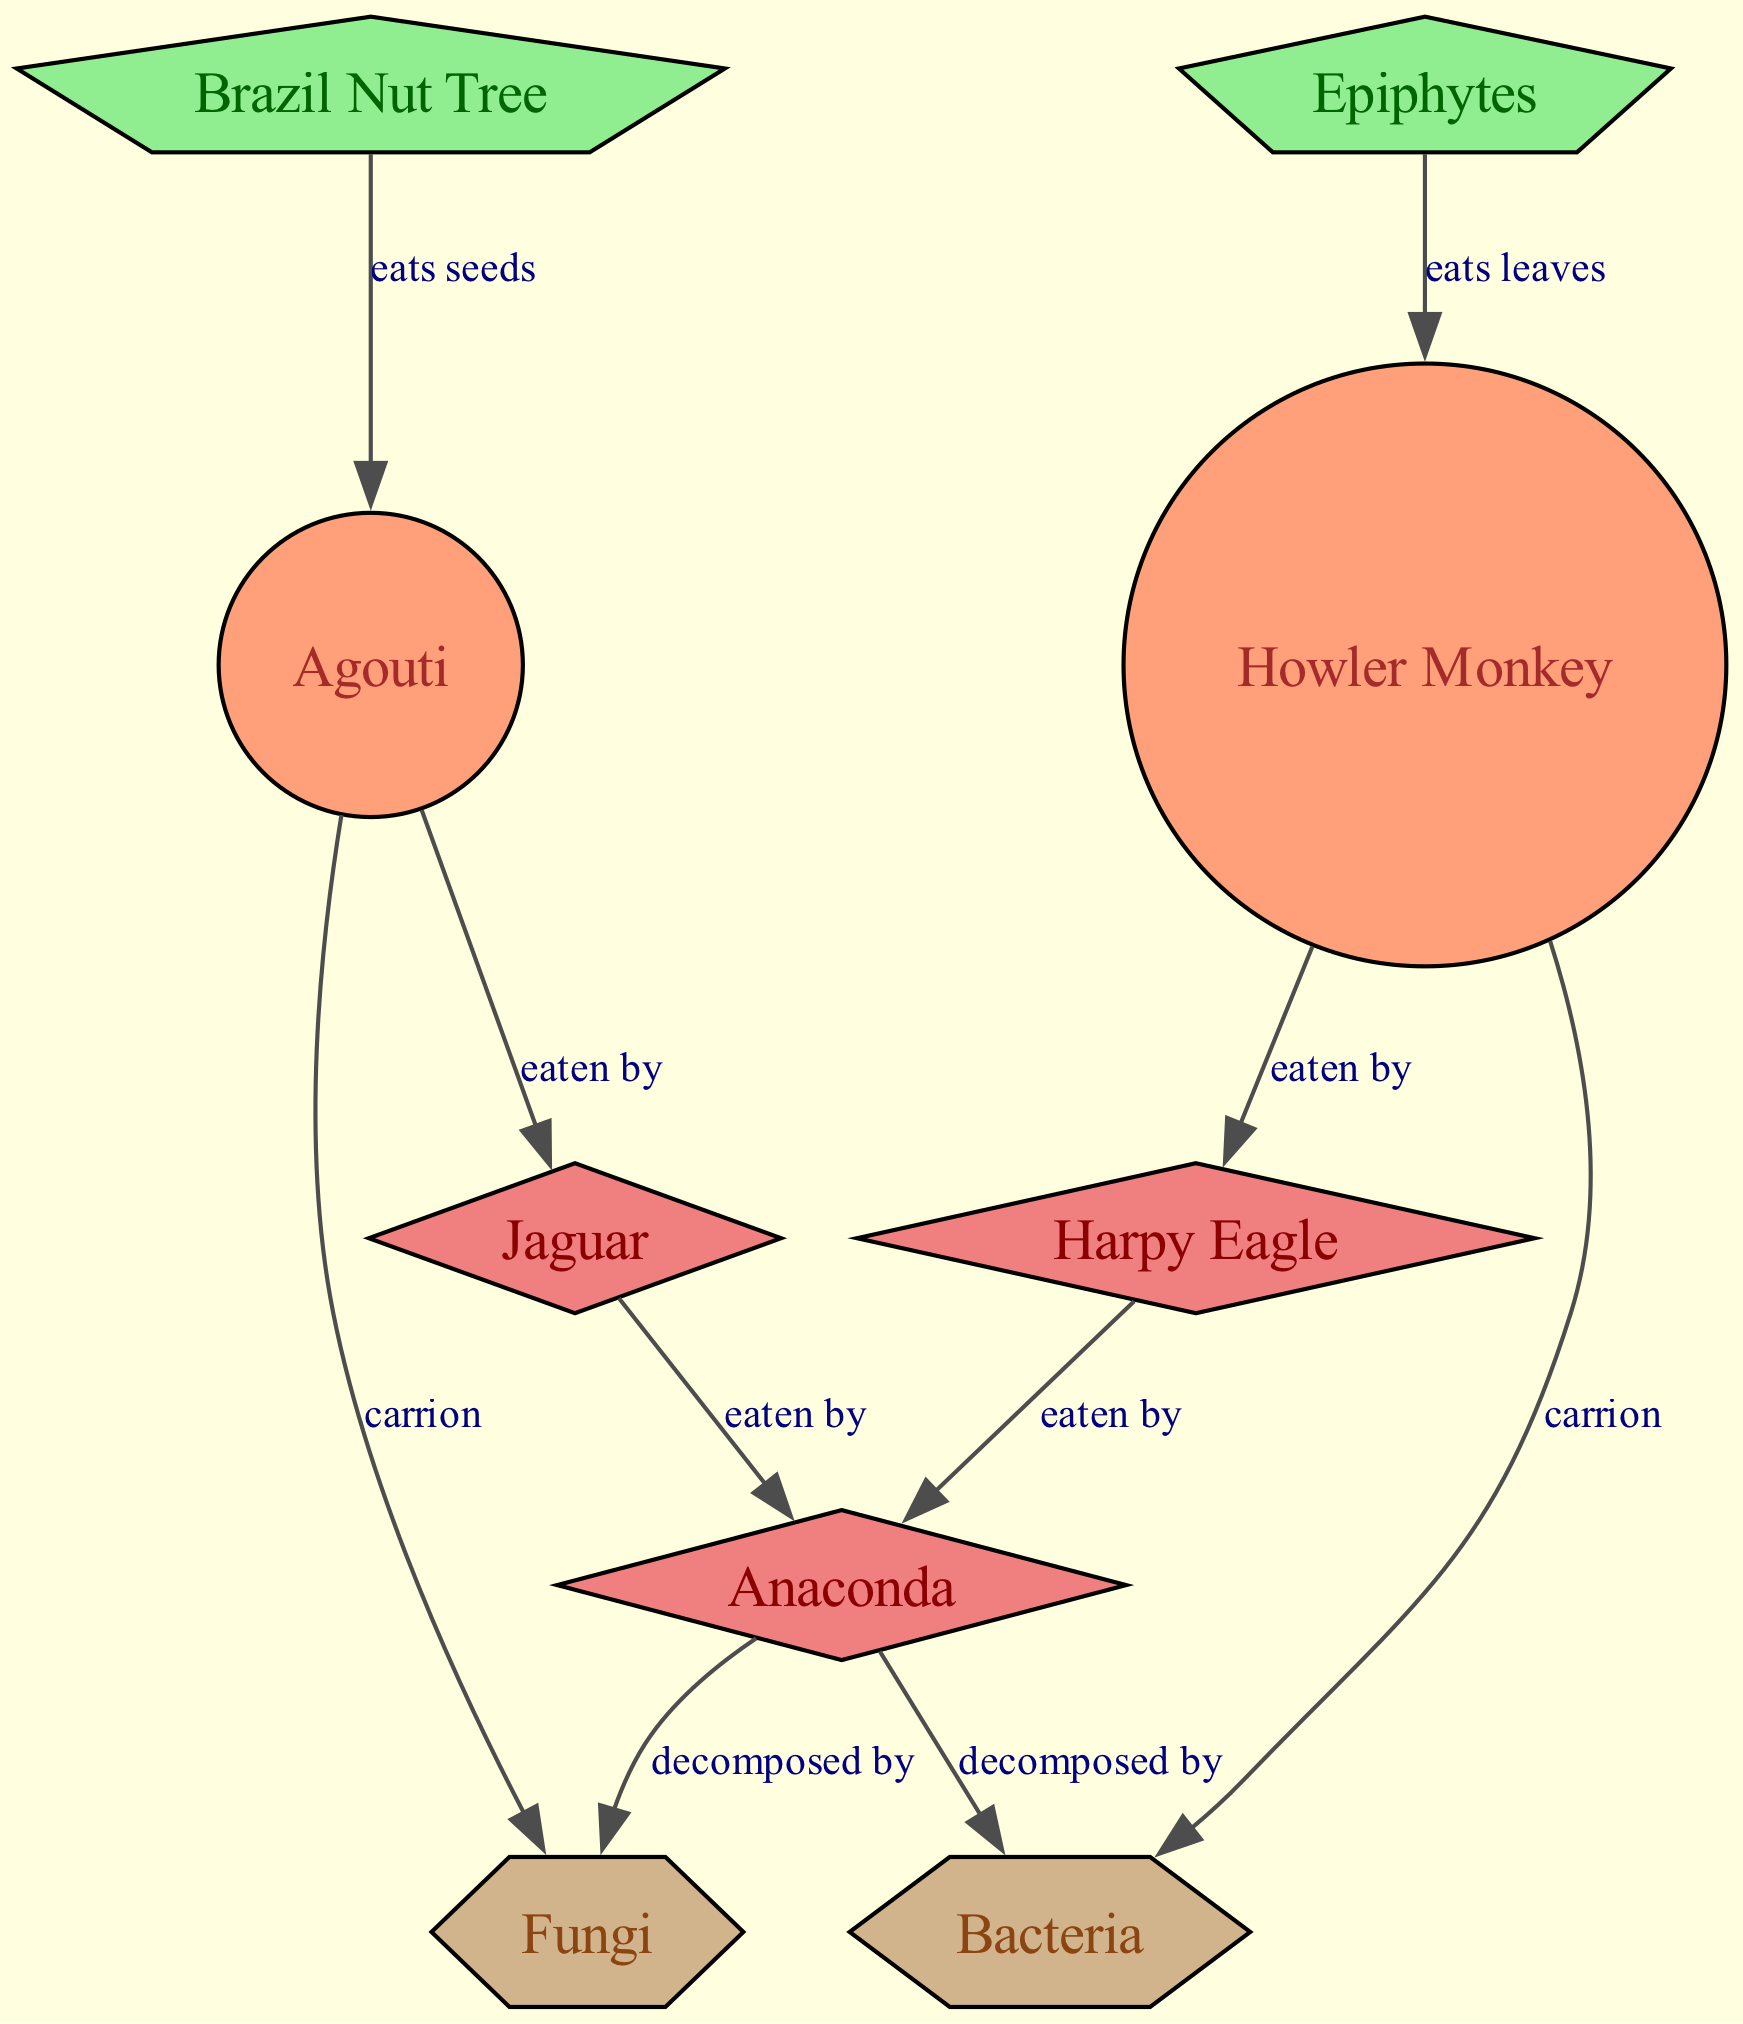What are the primary consumers in the diagram? The primary consumers are identified as herbivores in the diagram. By examining the nodes, the Agouti and Howler Monkey are listed as herbivores, which means they consume plant material.
Answer: Agouti, Howler Monkey How many producers are represented in the diagram? The nodes labeled as producers (plants) include the Brazil Nut Tree and Epiphytes. By counting these nodes, we can see there are two producers.
Answer: 2 Which secondary consumer eats the Agouti? The arrow from the Agouti leads to the Jaguar, indicating that the Jaguar is the secondary consumer that preys on the Agouti.
Answer: Jaguar What is the relationship between the Anaconda and the Harpy Eagle? The Anaconda is a tertiary consumer and is shown to be linked by arrows to both the Jaguar and Harpy Eagle, but there are no direct arrows connecting the Anaconda to the Harpy Eagle. The Harpy Eagle is eaten by the Anaconda, indicating a predatory relationship.
Answer: eaten by How many decomposers are included in the diagram? The nodes that represent decomposers are Fungi and Bacteria. The diagram includes these two types of decomposers, indicating the process of breaking down organic matter.
Answer: 2 Which plant does the Howler Monkey primarily consume? The Howler Monkey is linked by an arrow, which indicates the relationship, to the Epiphytes as the plant it consumes, according to the labeled relationship in the diagram.
Answer: Epiphytes Which three animals are classified as carnivores in the food web? The secondary consumers are the Jaguar and Harpy Eagle, with the Anaconda as the tertiary consumer. By identifying these nodes, we see they are all carnivores in the food web.
Answer: Jaguar, Harpy Eagle, Anaconda What is the common function of Fungi and Bacteria in the ecosystem represented? Both Fungi and Bacteria are categorized as decomposers in the food web diagram, which highlights their function in breaking down dead organic material, returning nutrients to the ecosystem.
Answer: decomposers 